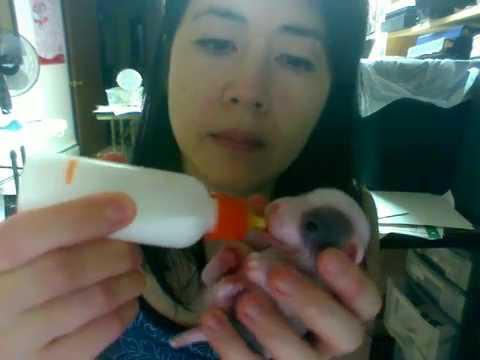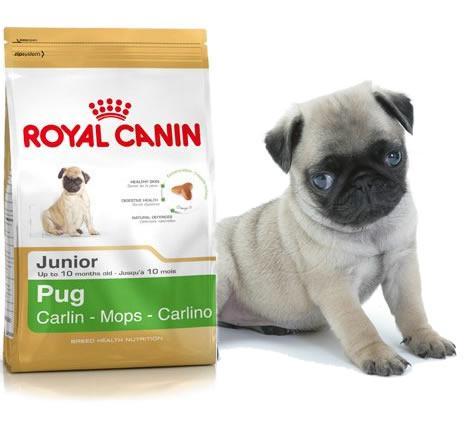The first image is the image on the left, the second image is the image on the right. Evaluate the accuracy of this statement regarding the images: "In one of the images you can see someone feeding a puppy from a bottle.". Is it true? Answer yes or no. Yes. The first image is the image on the left, the second image is the image on the right. For the images shown, is this caption "Someone is feeding a puppy with a baby bottle in one image, and the other image contains one 'real' pug dog." true? Answer yes or no. Yes. 